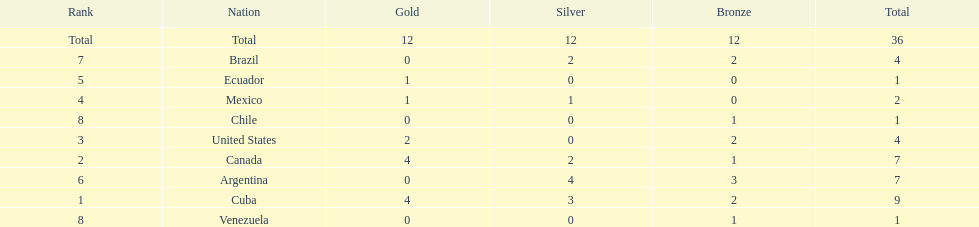Who had more silver medals, cuba or brazil? Cuba. 